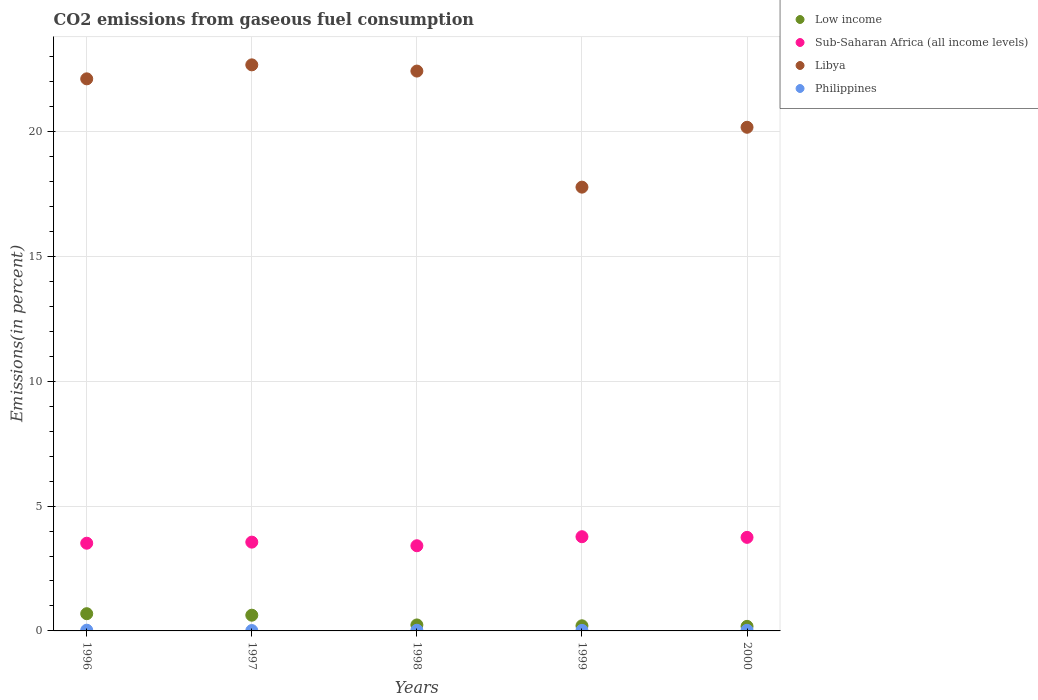What is the total CO2 emitted in Sub-Saharan Africa (all income levels) in 1998?
Your response must be concise. 3.41. Across all years, what is the maximum total CO2 emitted in Philippines?
Offer a very short reply. 0.03. Across all years, what is the minimum total CO2 emitted in Low income?
Offer a very short reply. 0.18. In which year was the total CO2 emitted in Libya maximum?
Keep it short and to the point. 1997. In which year was the total CO2 emitted in Sub-Saharan Africa (all income levels) minimum?
Ensure brevity in your answer.  1998. What is the total total CO2 emitted in Philippines in the graph?
Ensure brevity in your answer.  0.12. What is the difference between the total CO2 emitted in Libya in 1999 and that in 2000?
Your answer should be compact. -2.4. What is the difference between the total CO2 emitted in Low income in 1997 and the total CO2 emitted in Philippines in 2000?
Offer a very short reply. 0.6. What is the average total CO2 emitted in Sub-Saharan Africa (all income levels) per year?
Offer a very short reply. 3.6. In the year 1999, what is the difference between the total CO2 emitted in Philippines and total CO2 emitted in Low income?
Give a very brief answer. -0.18. In how many years, is the total CO2 emitted in Philippines greater than 11 %?
Provide a succinct answer. 0. What is the ratio of the total CO2 emitted in Philippines in 1997 to that in 2000?
Your answer should be compact. 0.62. What is the difference between the highest and the second highest total CO2 emitted in Libya?
Offer a terse response. 0.25. What is the difference between the highest and the lowest total CO2 emitted in Low income?
Offer a very short reply. 0.51. Is the sum of the total CO2 emitted in Low income in 1998 and 1999 greater than the maximum total CO2 emitted in Libya across all years?
Make the answer very short. No. Is it the case that in every year, the sum of the total CO2 emitted in Sub-Saharan Africa (all income levels) and total CO2 emitted in Low income  is greater than the total CO2 emitted in Philippines?
Provide a short and direct response. Yes. Does the total CO2 emitted in Libya monotonically increase over the years?
Give a very brief answer. No. Is the total CO2 emitted in Libya strictly greater than the total CO2 emitted in Philippines over the years?
Give a very brief answer. Yes. Are the values on the major ticks of Y-axis written in scientific E-notation?
Ensure brevity in your answer.  No. Does the graph contain any zero values?
Your answer should be very brief. No. How many legend labels are there?
Your answer should be very brief. 4. What is the title of the graph?
Keep it short and to the point. CO2 emissions from gaseous fuel consumption. Does "South Africa" appear as one of the legend labels in the graph?
Provide a short and direct response. No. What is the label or title of the X-axis?
Ensure brevity in your answer.  Years. What is the label or title of the Y-axis?
Give a very brief answer. Emissions(in percent). What is the Emissions(in percent) in Low income in 1996?
Provide a succinct answer. 0.69. What is the Emissions(in percent) in Sub-Saharan Africa (all income levels) in 1996?
Keep it short and to the point. 3.51. What is the Emissions(in percent) in Libya in 1996?
Your answer should be very brief. 22.11. What is the Emissions(in percent) of Philippines in 1996?
Offer a terse response. 0.03. What is the Emissions(in percent) in Low income in 1997?
Provide a succinct answer. 0.63. What is the Emissions(in percent) in Sub-Saharan Africa (all income levels) in 1997?
Ensure brevity in your answer.  3.56. What is the Emissions(in percent) of Libya in 1997?
Give a very brief answer. 22.67. What is the Emissions(in percent) of Philippines in 1997?
Ensure brevity in your answer.  0.02. What is the Emissions(in percent) of Low income in 1998?
Offer a terse response. 0.24. What is the Emissions(in percent) of Sub-Saharan Africa (all income levels) in 1998?
Offer a very short reply. 3.41. What is the Emissions(in percent) in Libya in 1998?
Your answer should be compact. 22.43. What is the Emissions(in percent) in Philippines in 1998?
Your answer should be very brief. 0.03. What is the Emissions(in percent) in Low income in 1999?
Ensure brevity in your answer.  0.21. What is the Emissions(in percent) in Sub-Saharan Africa (all income levels) in 1999?
Ensure brevity in your answer.  3.77. What is the Emissions(in percent) in Libya in 1999?
Provide a succinct answer. 17.78. What is the Emissions(in percent) of Philippines in 1999?
Your response must be concise. 0.02. What is the Emissions(in percent) in Low income in 2000?
Ensure brevity in your answer.  0.18. What is the Emissions(in percent) in Sub-Saharan Africa (all income levels) in 2000?
Offer a very short reply. 3.75. What is the Emissions(in percent) of Libya in 2000?
Your response must be concise. 20.17. What is the Emissions(in percent) in Philippines in 2000?
Give a very brief answer. 0.03. Across all years, what is the maximum Emissions(in percent) in Low income?
Your answer should be very brief. 0.69. Across all years, what is the maximum Emissions(in percent) in Sub-Saharan Africa (all income levels)?
Offer a terse response. 3.77. Across all years, what is the maximum Emissions(in percent) in Libya?
Your answer should be very brief. 22.67. Across all years, what is the maximum Emissions(in percent) of Philippines?
Make the answer very short. 0.03. Across all years, what is the minimum Emissions(in percent) of Low income?
Ensure brevity in your answer.  0.18. Across all years, what is the minimum Emissions(in percent) of Sub-Saharan Africa (all income levels)?
Keep it short and to the point. 3.41. Across all years, what is the minimum Emissions(in percent) of Libya?
Offer a very short reply. 17.78. Across all years, what is the minimum Emissions(in percent) in Philippines?
Your answer should be very brief. 0.02. What is the total Emissions(in percent) in Low income in the graph?
Your answer should be very brief. 1.95. What is the total Emissions(in percent) of Sub-Saharan Africa (all income levels) in the graph?
Provide a short and direct response. 18. What is the total Emissions(in percent) in Libya in the graph?
Your answer should be very brief. 105.16. What is the total Emissions(in percent) in Philippines in the graph?
Your answer should be very brief. 0.12. What is the difference between the Emissions(in percent) in Low income in 1996 and that in 1997?
Your answer should be compact. 0.06. What is the difference between the Emissions(in percent) in Sub-Saharan Africa (all income levels) in 1996 and that in 1997?
Keep it short and to the point. -0.04. What is the difference between the Emissions(in percent) in Libya in 1996 and that in 1997?
Provide a succinct answer. -0.56. What is the difference between the Emissions(in percent) of Philippines in 1996 and that in 1997?
Make the answer very short. 0.01. What is the difference between the Emissions(in percent) in Low income in 1996 and that in 1998?
Keep it short and to the point. 0.45. What is the difference between the Emissions(in percent) of Sub-Saharan Africa (all income levels) in 1996 and that in 1998?
Provide a succinct answer. 0.1. What is the difference between the Emissions(in percent) in Libya in 1996 and that in 1998?
Make the answer very short. -0.31. What is the difference between the Emissions(in percent) of Philippines in 1996 and that in 1998?
Provide a short and direct response. 0. What is the difference between the Emissions(in percent) in Low income in 1996 and that in 1999?
Your answer should be very brief. 0.48. What is the difference between the Emissions(in percent) of Sub-Saharan Africa (all income levels) in 1996 and that in 1999?
Your answer should be compact. -0.26. What is the difference between the Emissions(in percent) in Libya in 1996 and that in 1999?
Give a very brief answer. 4.34. What is the difference between the Emissions(in percent) of Philippines in 1996 and that in 1999?
Provide a succinct answer. 0.01. What is the difference between the Emissions(in percent) in Low income in 1996 and that in 2000?
Your answer should be very brief. 0.51. What is the difference between the Emissions(in percent) of Sub-Saharan Africa (all income levels) in 1996 and that in 2000?
Provide a succinct answer. -0.23. What is the difference between the Emissions(in percent) in Libya in 1996 and that in 2000?
Your answer should be very brief. 1.94. What is the difference between the Emissions(in percent) of Philippines in 1996 and that in 2000?
Your response must be concise. 0. What is the difference between the Emissions(in percent) of Low income in 1997 and that in 1998?
Your response must be concise. 0.39. What is the difference between the Emissions(in percent) in Sub-Saharan Africa (all income levels) in 1997 and that in 1998?
Give a very brief answer. 0.14. What is the difference between the Emissions(in percent) of Libya in 1997 and that in 1998?
Offer a terse response. 0.25. What is the difference between the Emissions(in percent) of Philippines in 1997 and that in 1998?
Your answer should be compact. -0.01. What is the difference between the Emissions(in percent) of Low income in 1997 and that in 1999?
Your response must be concise. 0.42. What is the difference between the Emissions(in percent) of Sub-Saharan Africa (all income levels) in 1997 and that in 1999?
Your response must be concise. -0.22. What is the difference between the Emissions(in percent) in Libya in 1997 and that in 1999?
Your answer should be compact. 4.9. What is the difference between the Emissions(in percent) of Philippines in 1997 and that in 1999?
Give a very brief answer. -0.01. What is the difference between the Emissions(in percent) of Low income in 1997 and that in 2000?
Provide a short and direct response. 0.45. What is the difference between the Emissions(in percent) in Sub-Saharan Africa (all income levels) in 1997 and that in 2000?
Give a very brief answer. -0.19. What is the difference between the Emissions(in percent) in Libya in 1997 and that in 2000?
Offer a terse response. 2.5. What is the difference between the Emissions(in percent) of Philippines in 1997 and that in 2000?
Offer a very short reply. -0.01. What is the difference between the Emissions(in percent) in Low income in 1998 and that in 1999?
Make the answer very short. 0.03. What is the difference between the Emissions(in percent) in Sub-Saharan Africa (all income levels) in 1998 and that in 1999?
Provide a short and direct response. -0.36. What is the difference between the Emissions(in percent) in Libya in 1998 and that in 1999?
Offer a terse response. 4.65. What is the difference between the Emissions(in percent) of Philippines in 1998 and that in 1999?
Your answer should be compact. 0.01. What is the difference between the Emissions(in percent) in Low income in 1998 and that in 2000?
Provide a short and direct response. 0.06. What is the difference between the Emissions(in percent) of Sub-Saharan Africa (all income levels) in 1998 and that in 2000?
Provide a succinct answer. -0.34. What is the difference between the Emissions(in percent) in Libya in 1998 and that in 2000?
Provide a succinct answer. 2.25. What is the difference between the Emissions(in percent) of Philippines in 1998 and that in 2000?
Provide a succinct answer. 0. What is the difference between the Emissions(in percent) in Low income in 1999 and that in 2000?
Give a very brief answer. 0.02. What is the difference between the Emissions(in percent) in Sub-Saharan Africa (all income levels) in 1999 and that in 2000?
Your response must be concise. 0.03. What is the difference between the Emissions(in percent) of Libya in 1999 and that in 2000?
Provide a short and direct response. -2.4. What is the difference between the Emissions(in percent) in Philippines in 1999 and that in 2000?
Offer a terse response. -0. What is the difference between the Emissions(in percent) in Low income in 1996 and the Emissions(in percent) in Sub-Saharan Africa (all income levels) in 1997?
Provide a short and direct response. -2.87. What is the difference between the Emissions(in percent) of Low income in 1996 and the Emissions(in percent) of Libya in 1997?
Offer a terse response. -21.98. What is the difference between the Emissions(in percent) in Low income in 1996 and the Emissions(in percent) in Philippines in 1997?
Offer a very short reply. 0.67. What is the difference between the Emissions(in percent) of Sub-Saharan Africa (all income levels) in 1996 and the Emissions(in percent) of Libya in 1997?
Your answer should be very brief. -19.16. What is the difference between the Emissions(in percent) in Sub-Saharan Africa (all income levels) in 1996 and the Emissions(in percent) in Philippines in 1997?
Offer a very short reply. 3.5. What is the difference between the Emissions(in percent) of Libya in 1996 and the Emissions(in percent) of Philippines in 1997?
Keep it short and to the point. 22.1. What is the difference between the Emissions(in percent) of Low income in 1996 and the Emissions(in percent) of Sub-Saharan Africa (all income levels) in 1998?
Provide a succinct answer. -2.72. What is the difference between the Emissions(in percent) in Low income in 1996 and the Emissions(in percent) in Libya in 1998?
Your response must be concise. -21.74. What is the difference between the Emissions(in percent) in Low income in 1996 and the Emissions(in percent) in Philippines in 1998?
Keep it short and to the point. 0.66. What is the difference between the Emissions(in percent) in Sub-Saharan Africa (all income levels) in 1996 and the Emissions(in percent) in Libya in 1998?
Your answer should be compact. -18.91. What is the difference between the Emissions(in percent) of Sub-Saharan Africa (all income levels) in 1996 and the Emissions(in percent) of Philippines in 1998?
Provide a short and direct response. 3.49. What is the difference between the Emissions(in percent) in Libya in 1996 and the Emissions(in percent) in Philippines in 1998?
Provide a succinct answer. 22.09. What is the difference between the Emissions(in percent) in Low income in 1996 and the Emissions(in percent) in Sub-Saharan Africa (all income levels) in 1999?
Your answer should be very brief. -3.08. What is the difference between the Emissions(in percent) in Low income in 1996 and the Emissions(in percent) in Libya in 1999?
Give a very brief answer. -17.09. What is the difference between the Emissions(in percent) in Low income in 1996 and the Emissions(in percent) in Philippines in 1999?
Offer a terse response. 0.67. What is the difference between the Emissions(in percent) in Sub-Saharan Africa (all income levels) in 1996 and the Emissions(in percent) in Libya in 1999?
Your answer should be very brief. -14.26. What is the difference between the Emissions(in percent) in Sub-Saharan Africa (all income levels) in 1996 and the Emissions(in percent) in Philippines in 1999?
Provide a short and direct response. 3.49. What is the difference between the Emissions(in percent) of Libya in 1996 and the Emissions(in percent) of Philippines in 1999?
Give a very brief answer. 22.09. What is the difference between the Emissions(in percent) of Low income in 1996 and the Emissions(in percent) of Sub-Saharan Africa (all income levels) in 2000?
Your answer should be very brief. -3.06. What is the difference between the Emissions(in percent) of Low income in 1996 and the Emissions(in percent) of Libya in 2000?
Your response must be concise. -19.48. What is the difference between the Emissions(in percent) of Low income in 1996 and the Emissions(in percent) of Philippines in 2000?
Keep it short and to the point. 0.66. What is the difference between the Emissions(in percent) of Sub-Saharan Africa (all income levels) in 1996 and the Emissions(in percent) of Libya in 2000?
Ensure brevity in your answer.  -16.66. What is the difference between the Emissions(in percent) of Sub-Saharan Africa (all income levels) in 1996 and the Emissions(in percent) of Philippines in 2000?
Keep it short and to the point. 3.49. What is the difference between the Emissions(in percent) in Libya in 1996 and the Emissions(in percent) in Philippines in 2000?
Your answer should be compact. 22.09. What is the difference between the Emissions(in percent) in Low income in 1997 and the Emissions(in percent) in Sub-Saharan Africa (all income levels) in 1998?
Your response must be concise. -2.78. What is the difference between the Emissions(in percent) in Low income in 1997 and the Emissions(in percent) in Libya in 1998?
Provide a short and direct response. -21.8. What is the difference between the Emissions(in percent) in Low income in 1997 and the Emissions(in percent) in Philippines in 1998?
Your answer should be compact. 0.6. What is the difference between the Emissions(in percent) of Sub-Saharan Africa (all income levels) in 1997 and the Emissions(in percent) of Libya in 1998?
Offer a very short reply. -18.87. What is the difference between the Emissions(in percent) in Sub-Saharan Africa (all income levels) in 1997 and the Emissions(in percent) in Philippines in 1998?
Keep it short and to the point. 3.53. What is the difference between the Emissions(in percent) of Libya in 1997 and the Emissions(in percent) of Philippines in 1998?
Offer a terse response. 22.65. What is the difference between the Emissions(in percent) in Low income in 1997 and the Emissions(in percent) in Sub-Saharan Africa (all income levels) in 1999?
Provide a short and direct response. -3.14. What is the difference between the Emissions(in percent) in Low income in 1997 and the Emissions(in percent) in Libya in 1999?
Your answer should be compact. -17.15. What is the difference between the Emissions(in percent) in Low income in 1997 and the Emissions(in percent) in Philippines in 1999?
Keep it short and to the point. 0.61. What is the difference between the Emissions(in percent) in Sub-Saharan Africa (all income levels) in 1997 and the Emissions(in percent) in Libya in 1999?
Your answer should be compact. -14.22. What is the difference between the Emissions(in percent) in Sub-Saharan Africa (all income levels) in 1997 and the Emissions(in percent) in Philippines in 1999?
Keep it short and to the point. 3.54. What is the difference between the Emissions(in percent) in Libya in 1997 and the Emissions(in percent) in Philippines in 1999?
Provide a short and direct response. 22.65. What is the difference between the Emissions(in percent) in Low income in 1997 and the Emissions(in percent) in Sub-Saharan Africa (all income levels) in 2000?
Your answer should be very brief. -3.12. What is the difference between the Emissions(in percent) in Low income in 1997 and the Emissions(in percent) in Libya in 2000?
Your answer should be compact. -19.54. What is the difference between the Emissions(in percent) of Low income in 1997 and the Emissions(in percent) of Philippines in 2000?
Provide a short and direct response. 0.6. What is the difference between the Emissions(in percent) of Sub-Saharan Africa (all income levels) in 1997 and the Emissions(in percent) of Libya in 2000?
Keep it short and to the point. -16.62. What is the difference between the Emissions(in percent) of Sub-Saharan Africa (all income levels) in 1997 and the Emissions(in percent) of Philippines in 2000?
Your answer should be very brief. 3.53. What is the difference between the Emissions(in percent) of Libya in 1997 and the Emissions(in percent) of Philippines in 2000?
Make the answer very short. 22.65. What is the difference between the Emissions(in percent) in Low income in 1998 and the Emissions(in percent) in Sub-Saharan Africa (all income levels) in 1999?
Provide a succinct answer. -3.53. What is the difference between the Emissions(in percent) in Low income in 1998 and the Emissions(in percent) in Libya in 1999?
Keep it short and to the point. -17.54. What is the difference between the Emissions(in percent) of Low income in 1998 and the Emissions(in percent) of Philippines in 1999?
Provide a succinct answer. 0.22. What is the difference between the Emissions(in percent) in Sub-Saharan Africa (all income levels) in 1998 and the Emissions(in percent) in Libya in 1999?
Your answer should be compact. -14.36. What is the difference between the Emissions(in percent) of Sub-Saharan Africa (all income levels) in 1998 and the Emissions(in percent) of Philippines in 1999?
Offer a very short reply. 3.39. What is the difference between the Emissions(in percent) in Libya in 1998 and the Emissions(in percent) in Philippines in 1999?
Provide a succinct answer. 22.4. What is the difference between the Emissions(in percent) of Low income in 1998 and the Emissions(in percent) of Sub-Saharan Africa (all income levels) in 2000?
Your response must be concise. -3.51. What is the difference between the Emissions(in percent) in Low income in 1998 and the Emissions(in percent) in Libya in 2000?
Ensure brevity in your answer.  -19.93. What is the difference between the Emissions(in percent) of Low income in 1998 and the Emissions(in percent) of Philippines in 2000?
Your response must be concise. 0.21. What is the difference between the Emissions(in percent) of Sub-Saharan Africa (all income levels) in 1998 and the Emissions(in percent) of Libya in 2000?
Offer a terse response. -16.76. What is the difference between the Emissions(in percent) of Sub-Saharan Africa (all income levels) in 1998 and the Emissions(in percent) of Philippines in 2000?
Provide a short and direct response. 3.39. What is the difference between the Emissions(in percent) of Libya in 1998 and the Emissions(in percent) of Philippines in 2000?
Keep it short and to the point. 22.4. What is the difference between the Emissions(in percent) in Low income in 1999 and the Emissions(in percent) in Sub-Saharan Africa (all income levels) in 2000?
Give a very brief answer. -3.54. What is the difference between the Emissions(in percent) in Low income in 1999 and the Emissions(in percent) in Libya in 2000?
Provide a short and direct response. -19.97. What is the difference between the Emissions(in percent) of Low income in 1999 and the Emissions(in percent) of Philippines in 2000?
Provide a succinct answer. 0.18. What is the difference between the Emissions(in percent) of Sub-Saharan Africa (all income levels) in 1999 and the Emissions(in percent) of Libya in 2000?
Provide a succinct answer. -16.4. What is the difference between the Emissions(in percent) in Sub-Saharan Africa (all income levels) in 1999 and the Emissions(in percent) in Philippines in 2000?
Provide a short and direct response. 3.75. What is the difference between the Emissions(in percent) of Libya in 1999 and the Emissions(in percent) of Philippines in 2000?
Give a very brief answer. 17.75. What is the average Emissions(in percent) in Low income per year?
Offer a terse response. 0.39. What is the average Emissions(in percent) of Sub-Saharan Africa (all income levels) per year?
Your answer should be very brief. 3.6. What is the average Emissions(in percent) in Libya per year?
Your answer should be compact. 21.03. What is the average Emissions(in percent) of Philippines per year?
Your response must be concise. 0.02. In the year 1996, what is the difference between the Emissions(in percent) of Low income and Emissions(in percent) of Sub-Saharan Africa (all income levels)?
Your answer should be compact. -2.82. In the year 1996, what is the difference between the Emissions(in percent) of Low income and Emissions(in percent) of Libya?
Make the answer very short. -21.42. In the year 1996, what is the difference between the Emissions(in percent) of Low income and Emissions(in percent) of Philippines?
Your answer should be very brief. 0.66. In the year 1996, what is the difference between the Emissions(in percent) of Sub-Saharan Africa (all income levels) and Emissions(in percent) of Libya?
Ensure brevity in your answer.  -18.6. In the year 1996, what is the difference between the Emissions(in percent) in Sub-Saharan Africa (all income levels) and Emissions(in percent) in Philippines?
Offer a very short reply. 3.48. In the year 1996, what is the difference between the Emissions(in percent) of Libya and Emissions(in percent) of Philippines?
Your response must be concise. 22.08. In the year 1997, what is the difference between the Emissions(in percent) of Low income and Emissions(in percent) of Sub-Saharan Africa (all income levels)?
Your answer should be compact. -2.93. In the year 1997, what is the difference between the Emissions(in percent) of Low income and Emissions(in percent) of Libya?
Provide a succinct answer. -22.04. In the year 1997, what is the difference between the Emissions(in percent) in Low income and Emissions(in percent) in Philippines?
Your response must be concise. 0.61. In the year 1997, what is the difference between the Emissions(in percent) of Sub-Saharan Africa (all income levels) and Emissions(in percent) of Libya?
Offer a terse response. -19.12. In the year 1997, what is the difference between the Emissions(in percent) of Sub-Saharan Africa (all income levels) and Emissions(in percent) of Philippines?
Your answer should be compact. 3.54. In the year 1997, what is the difference between the Emissions(in percent) in Libya and Emissions(in percent) in Philippines?
Offer a terse response. 22.66. In the year 1998, what is the difference between the Emissions(in percent) in Low income and Emissions(in percent) in Sub-Saharan Africa (all income levels)?
Your response must be concise. -3.17. In the year 1998, what is the difference between the Emissions(in percent) of Low income and Emissions(in percent) of Libya?
Your answer should be compact. -22.19. In the year 1998, what is the difference between the Emissions(in percent) of Low income and Emissions(in percent) of Philippines?
Keep it short and to the point. 0.21. In the year 1998, what is the difference between the Emissions(in percent) in Sub-Saharan Africa (all income levels) and Emissions(in percent) in Libya?
Make the answer very short. -19.01. In the year 1998, what is the difference between the Emissions(in percent) in Sub-Saharan Africa (all income levels) and Emissions(in percent) in Philippines?
Provide a short and direct response. 3.39. In the year 1998, what is the difference between the Emissions(in percent) in Libya and Emissions(in percent) in Philippines?
Ensure brevity in your answer.  22.4. In the year 1999, what is the difference between the Emissions(in percent) in Low income and Emissions(in percent) in Sub-Saharan Africa (all income levels)?
Provide a succinct answer. -3.57. In the year 1999, what is the difference between the Emissions(in percent) in Low income and Emissions(in percent) in Libya?
Offer a very short reply. -17.57. In the year 1999, what is the difference between the Emissions(in percent) in Low income and Emissions(in percent) in Philippines?
Make the answer very short. 0.18. In the year 1999, what is the difference between the Emissions(in percent) in Sub-Saharan Africa (all income levels) and Emissions(in percent) in Libya?
Provide a succinct answer. -14. In the year 1999, what is the difference between the Emissions(in percent) in Sub-Saharan Africa (all income levels) and Emissions(in percent) in Philippines?
Your answer should be very brief. 3.75. In the year 1999, what is the difference between the Emissions(in percent) of Libya and Emissions(in percent) of Philippines?
Your answer should be very brief. 17.75. In the year 2000, what is the difference between the Emissions(in percent) in Low income and Emissions(in percent) in Sub-Saharan Africa (all income levels)?
Provide a short and direct response. -3.56. In the year 2000, what is the difference between the Emissions(in percent) of Low income and Emissions(in percent) of Libya?
Make the answer very short. -19.99. In the year 2000, what is the difference between the Emissions(in percent) of Low income and Emissions(in percent) of Philippines?
Offer a terse response. 0.16. In the year 2000, what is the difference between the Emissions(in percent) in Sub-Saharan Africa (all income levels) and Emissions(in percent) in Libya?
Your answer should be very brief. -16.43. In the year 2000, what is the difference between the Emissions(in percent) in Sub-Saharan Africa (all income levels) and Emissions(in percent) in Philippines?
Ensure brevity in your answer.  3.72. In the year 2000, what is the difference between the Emissions(in percent) of Libya and Emissions(in percent) of Philippines?
Give a very brief answer. 20.15. What is the ratio of the Emissions(in percent) in Low income in 1996 to that in 1997?
Your answer should be very brief. 1.1. What is the ratio of the Emissions(in percent) of Sub-Saharan Africa (all income levels) in 1996 to that in 1997?
Keep it short and to the point. 0.99. What is the ratio of the Emissions(in percent) of Libya in 1996 to that in 1997?
Offer a terse response. 0.98. What is the ratio of the Emissions(in percent) of Philippines in 1996 to that in 1997?
Your answer should be very brief. 1.91. What is the ratio of the Emissions(in percent) in Low income in 1996 to that in 1998?
Give a very brief answer. 2.88. What is the ratio of the Emissions(in percent) of Sub-Saharan Africa (all income levels) in 1996 to that in 1998?
Offer a very short reply. 1.03. What is the ratio of the Emissions(in percent) in Libya in 1996 to that in 1998?
Your answer should be very brief. 0.99. What is the ratio of the Emissions(in percent) of Philippines in 1996 to that in 1998?
Your answer should be compact. 1.11. What is the ratio of the Emissions(in percent) in Low income in 1996 to that in 1999?
Offer a terse response. 3.36. What is the ratio of the Emissions(in percent) in Libya in 1996 to that in 1999?
Give a very brief answer. 1.24. What is the ratio of the Emissions(in percent) of Philippines in 1996 to that in 1999?
Make the answer very short. 1.39. What is the ratio of the Emissions(in percent) in Low income in 1996 to that in 2000?
Make the answer very short. 3.77. What is the ratio of the Emissions(in percent) in Sub-Saharan Africa (all income levels) in 1996 to that in 2000?
Offer a very short reply. 0.94. What is the ratio of the Emissions(in percent) in Libya in 1996 to that in 2000?
Keep it short and to the point. 1.1. What is the ratio of the Emissions(in percent) in Philippines in 1996 to that in 2000?
Provide a succinct answer. 1.18. What is the ratio of the Emissions(in percent) of Low income in 1997 to that in 1998?
Provide a succinct answer. 2.63. What is the ratio of the Emissions(in percent) in Sub-Saharan Africa (all income levels) in 1997 to that in 1998?
Your answer should be very brief. 1.04. What is the ratio of the Emissions(in percent) of Libya in 1997 to that in 1998?
Keep it short and to the point. 1.01. What is the ratio of the Emissions(in percent) of Philippines in 1997 to that in 1998?
Your answer should be compact. 0.58. What is the ratio of the Emissions(in percent) of Low income in 1997 to that in 1999?
Ensure brevity in your answer.  3.07. What is the ratio of the Emissions(in percent) of Sub-Saharan Africa (all income levels) in 1997 to that in 1999?
Ensure brevity in your answer.  0.94. What is the ratio of the Emissions(in percent) in Libya in 1997 to that in 1999?
Provide a short and direct response. 1.28. What is the ratio of the Emissions(in percent) of Philippines in 1997 to that in 1999?
Give a very brief answer. 0.73. What is the ratio of the Emissions(in percent) in Low income in 1997 to that in 2000?
Your answer should be compact. 3.44. What is the ratio of the Emissions(in percent) of Sub-Saharan Africa (all income levels) in 1997 to that in 2000?
Provide a short and direct response. 0.95. What is the ratio of the Emissions(in percent) in Libya in 1997 to that in 2000?
Your response must be concise. 1.12. What is the ratio of the Emissions(in percent) of Philippines in 1997 to that in 2000?
Your response must be concise. 0.62. What is the ratio of the Emissions(in percent) in Low income in 1998 to that in 1999?
Offer a very short reply. 1.17. What is the ratio of the Emissions(in percent) of Sub-Saharan Africa (all income levels) in 1998 to that in 1999?
Your response must be concise. 0.9. What is the ratio of the Emissions(in percent) in Libya in 1998 to that in 1999?
Your answer should be very brief. 1.26. What is the ratio of the Emissions(in percent) of Philippines in 1998 to that in 1999?
Your answer should be very brief. 1.25. What is the ratio of the Emissions(in percent) in Low income in 1998 to that in 2000?
Make the answer very short. 1.31. What is the ratio of the Emissions(in percent) in Sub-Saharan Africa (all income levels) in 1998 to that in 2000?
Offer a very short reply. 0.91. What is the ratio of the Emissions(in percent) in Libya in 1998 to that in 2000?
Give a very brief answer. 1.11. What is the ratio of the Emissions(in percent) in Philippines in 1998 to that in 2000?
Keep it short and to the point. 1.06. What is the ratio of the Emissions(in percent) in Low income in 1999 to that in 2000?
Offer a terse response. 1.12. What is the ratio of the Emissions(in percent) in Sub-Saharan Africa (all income levels) in 1999 to that in 2000?
Your answer should be compact. 1.01. What is the ratio of the Emissions(in percent) in Libya in 1999 to that in 2000?
Ensure brevity in your answer.  0.88. What is the ratio of the Emissions(in percent) in Philippines in 1999 to that in 2000?
Your answer should be very brief. 0.85. What is the difference between the highest and the second highest Emissions(in percent) in Low income?
Ensure brevity in your answer.  0.06. What is the difference between the highest and the second highest Emissions(in percent) in Sub-Saharan Africa (all income levels)?
Your answer should be very brief. 0.03. What is the difference between the highest and the second highest Emissions(in percent) of Libya?
Your answer should be compact. 0.25. What is the difference between the highest and the second highest Emissions(in percent) of Philippines?
Give a very brief answer. 0. What is the difference between the highest and the lowest Emissions(in percent) of Low income?
Your answer should be very brief. 0.51. What is the difference between the highest and the lowest Emissions(in percent) in Sub-Saharan Africa (all income levels)?
Your answer should be very brief. 0.36. What is the difference between the highest and the lowest Emissions(in percent) in Libya?
Ensure brevity in your answer.  4.9. What is the difference between the highest and the lowest Emissions(in percent) in Philippines?
Provide a short and direct response. 0.01. 